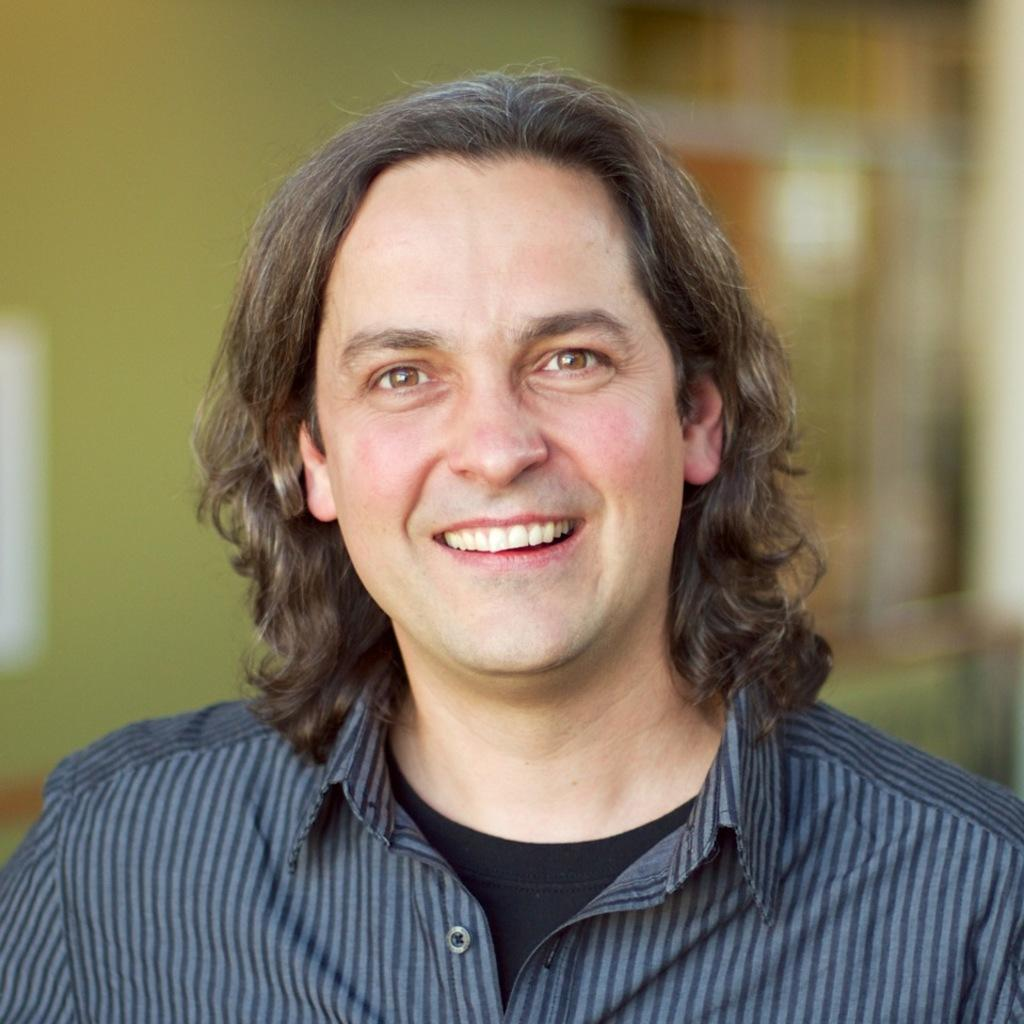Who is present in the image? There is a man in the image. What is the man's facial expression? The man is smiling. Can you describe the background of the image? The background of the image is blurred. What type of plastic is covering the news in the image? There is no plastic or news present in the image; it features a man with a blurred background. 